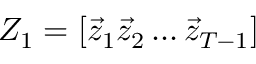<formula> <loc_0><loc_0><loc_500><loc_500>Z _ { 1 } = [ \vec { z } _ { 1 } \vec { z } _ { 2 } \dots \vec { z } _ { T - 1 } ]</formula> 